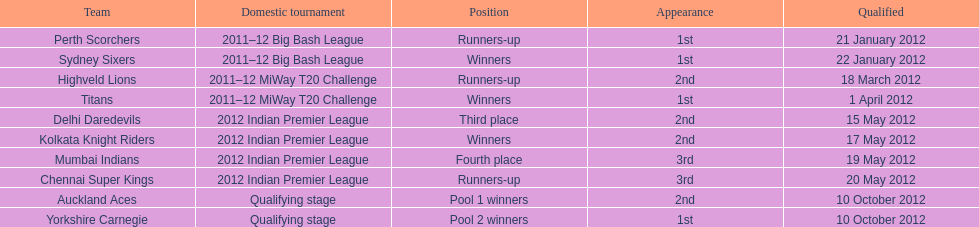Total number of teams that made it through the qualification - how many are they? 10. 